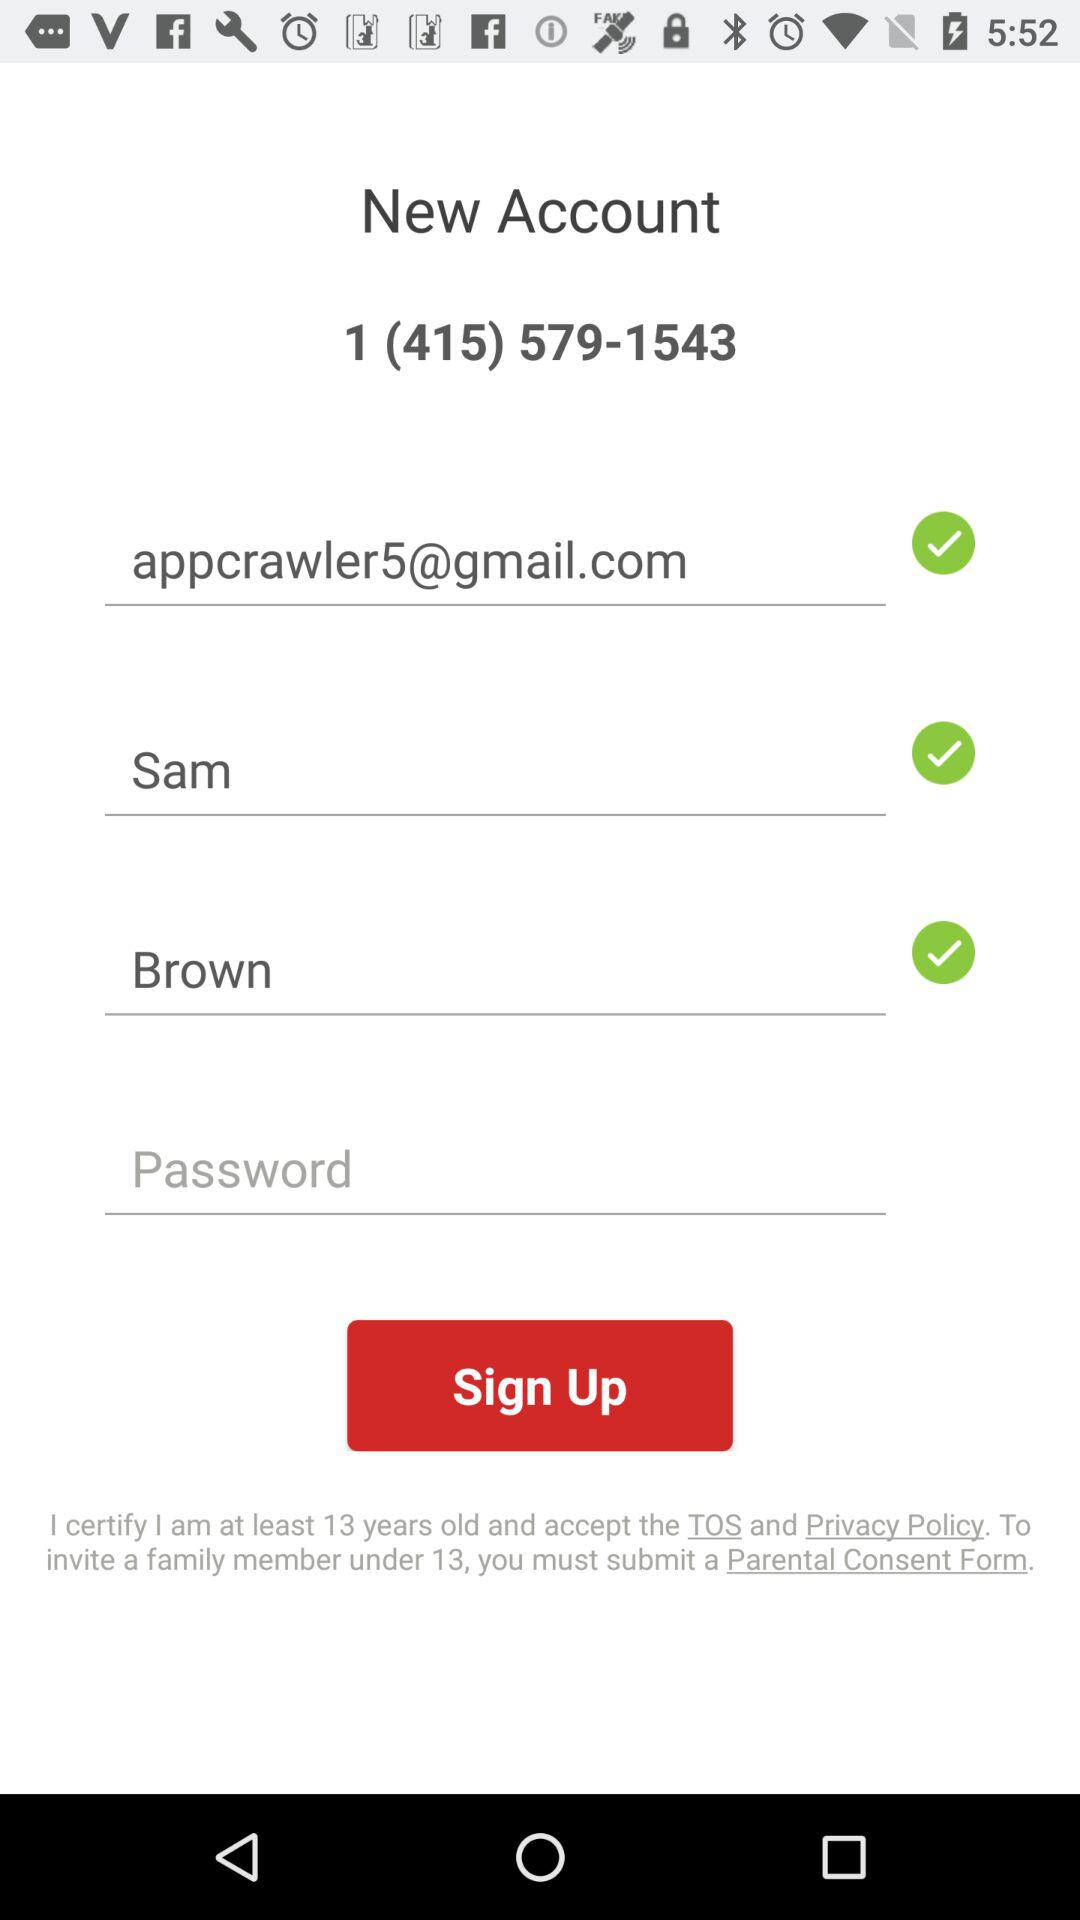What is the first name? The first name is Sam. 